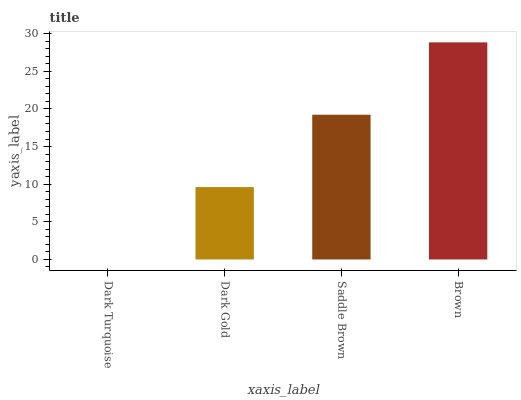Is Dark Turquoise the minimum?
Answer yes or no. Yes. Is Brown the maximum?
Answer yes or no. Yes. Is Dark Gold the minimum?
Answer yes or no. No. Is Dark Gold the maximum?
Answer yes or no. No. Is Dark Gold greater than Dark Turquoise?
Answer yes or no. Yes. Is Dark Turquoise less than Dark Gold?
Answer yes or no. Yes. Is Dark Turquoise greater than Dark Gold?
Answer yes or no. No. Is Dark Gold less than Dark Turquoise?
Answer yes or no. No. Is Saddle Brown the high median?
Answer yes or no. Yes. Is Dark Gold the low median?
Answer yes or no. Yes. Is Brown the high median?
Answer yes or no. No. Is Brown the low median?
Answer yes or no. No. 